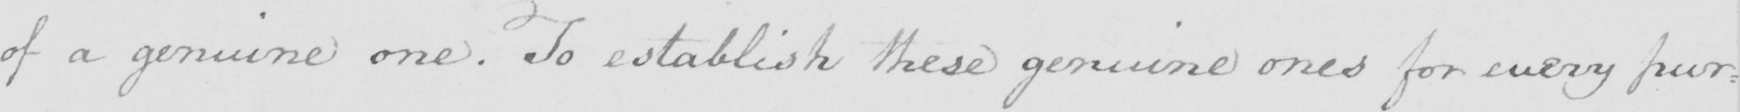What text is written in this handwritten line? of a genuine one. To establish these genuine ones for every pur: 